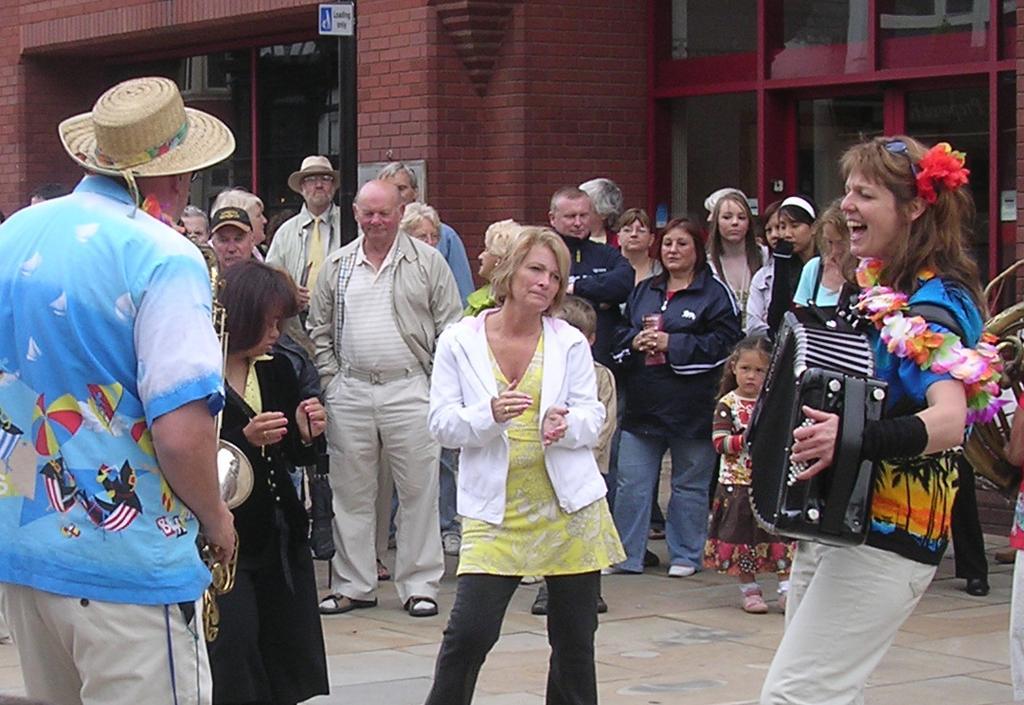Can you describe this image briefly? In this image, there are group of people standing on the road and watching the two musicians who are performing two instruments here and here. The background wall is brown in color and a door visible and a board visible. On the right top window is visible. It looks as if the image is taken on the road during day time. 